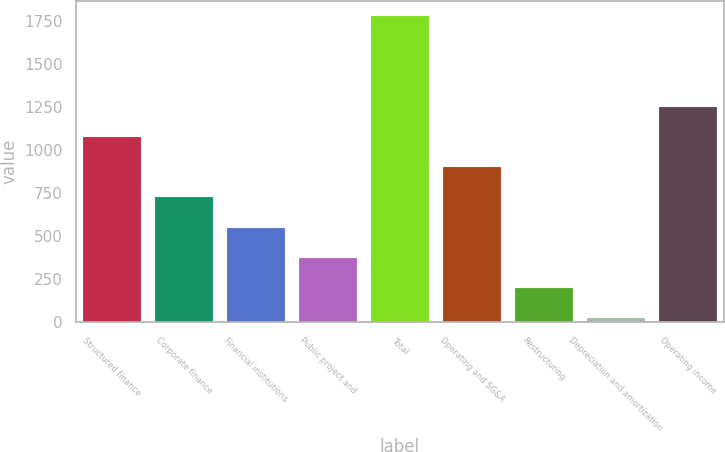Convert chart. <chart><loc_0><loc_0><loc_500><loc_500><bar_chart><fcel>Structured finance<fcel>Corporate finance<fcel>Financial institutions<fcel>Public project and<fcel>Total<fcel>Operating and SG&A<fcel>Restructuring<fcel>Depreciation and amortization<fcel>Operating income<nl><fcel>1077.54<fcel>726.36<fcel>550.77<fcel>375.18<fcel>1779.9<fcel>901.95<fcel>199.59<fcel>24<fcel>1253.13<nl></chart> 